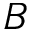Convert formula to latex. <formula><loc_0><loc_0><loc_500><loc_500>B</formula> 